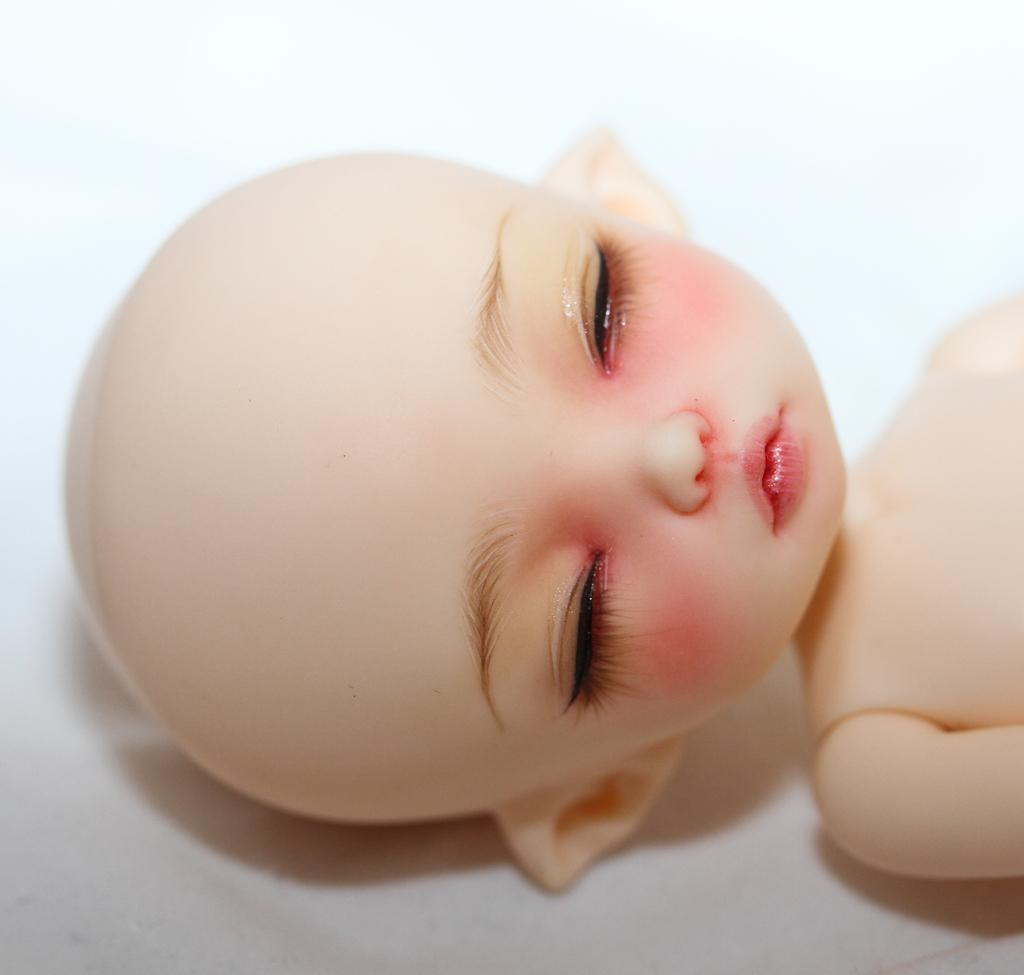What is the main subject in the image? There is a doll in the image. Where is the doll located? The doll is on a surface. What type of music can be heard coming from the doll in the image? There is no music coming from the doll in the image, as it is a static object and not capable of producing sound. 